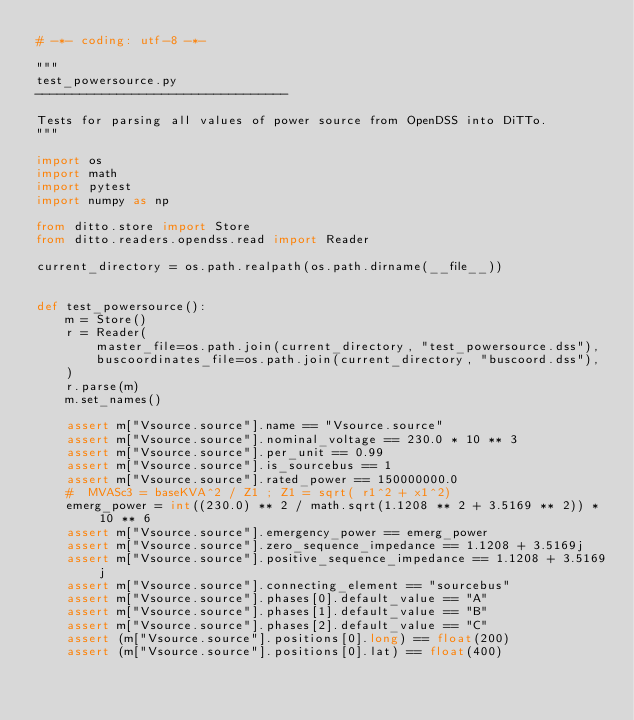Convert code to text. <code><loc_0><loc_0><loc_500><loc_500><_Python_># -*- coding: utf-8 -*-

"""
test_powersource.py
----------------------------------

Tests for parsing all values of power source from OpenDSS into DiTTo.
"""

import os
import math
import pytest
import numpy as np

from ditto.store import Store
from ditto.readers.opendss.read import Reader

current_directory = os.path.realpath(os.path.dirname(__file__))


def test_powersource():
    m = Store()
    r = Reader(
        master_file=os.path.join(current_directory, "test_powersource.dss"),
        buscoordinates_file=os.path.join(current_directory, "buscoord.dss"),
    )
    r.parse(m)
    m.set_names()

    assert m["Vsource.source"].name == "Vsource.source"
    assert m["Vsource.source"].nominal_voltage == 230.0 * 10 ** 3
    assert m["Vsource.source"].per_unit == 0.99
    assert m["Vsource.source"].is_sourcebus == 1
    assert m["Vsource.source"].rated_power == 150000000.0
    #  MVASc3 = baseKVA^2 / Z1 ; Z1 = sqrt( r1^2 + x1^2)
    emerg_power = int((230.0) ** 2 / math.sqrt(1.1208 ** 2 + 3.5169 ** 2)) * 10 ** 6
    assert m["Vsource.source"].emergency_power == emerg_power
    assert m["Vsource.source"].zero_sequence_impedance == 1.1208 + 3.5169j
    assert m["Vsource.source"].positive_sequence_impedance == 1.1208 + 3.5169j
    assert m["Vsource.source"].connecting_element == "sourcebus"
    assert m["Vsource.source"].phases[0].default_value == "A"
    assert m["Vsource.source"].phases[1].default_value == "B"
    assert m["Vsource.source"].phases[2].default_value == "C"
    assert (m["Vsource.source"].positions[0].long) == float(200)
    assert (m["Vsource.source"].positions[0].lat) == float(400)
</code> 